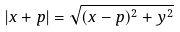<formula> <loc_0><loc_0><loc_500><loc_500>| x + p | = \sqrt { ( x - p ) ^ { 2 } + y ^ { 2 } }</formula> 